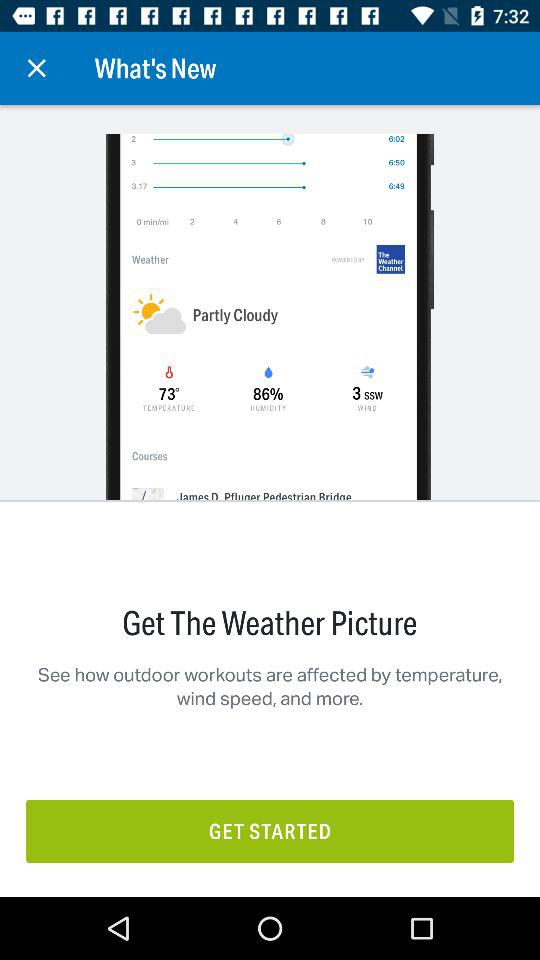What is the given temperature? The given temperature is 73 °. 